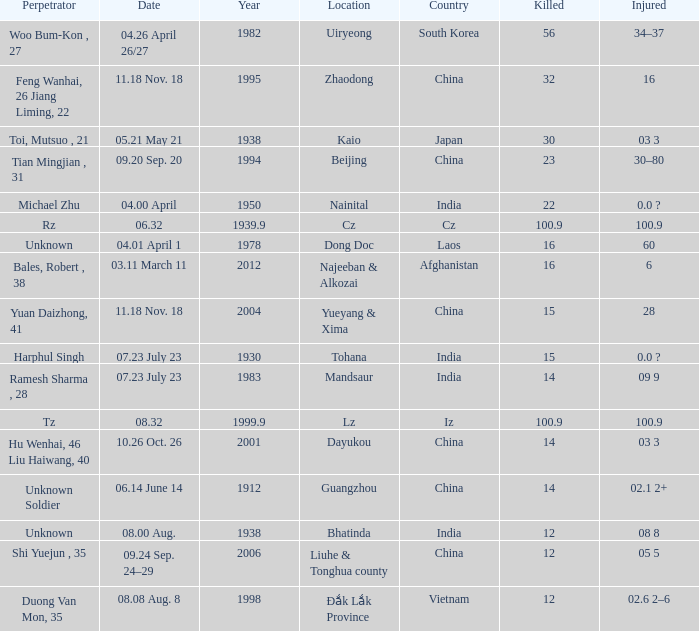What is Date, when Country is "China", and when Perpetrator is "Shi Yuejun , 35"? 09.24 Sep. 24–29. 